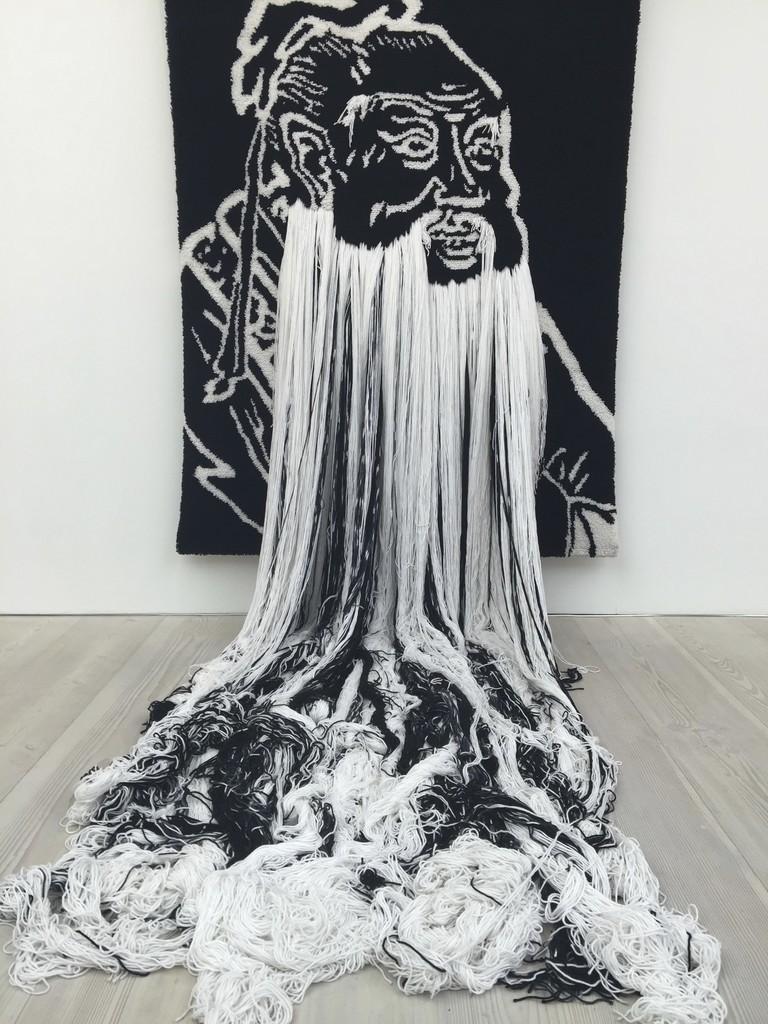How would you summarize this image in a sentence or two? In this picture I can see a art on the cloth and a wall in the background. I can see few threads on the floor. 